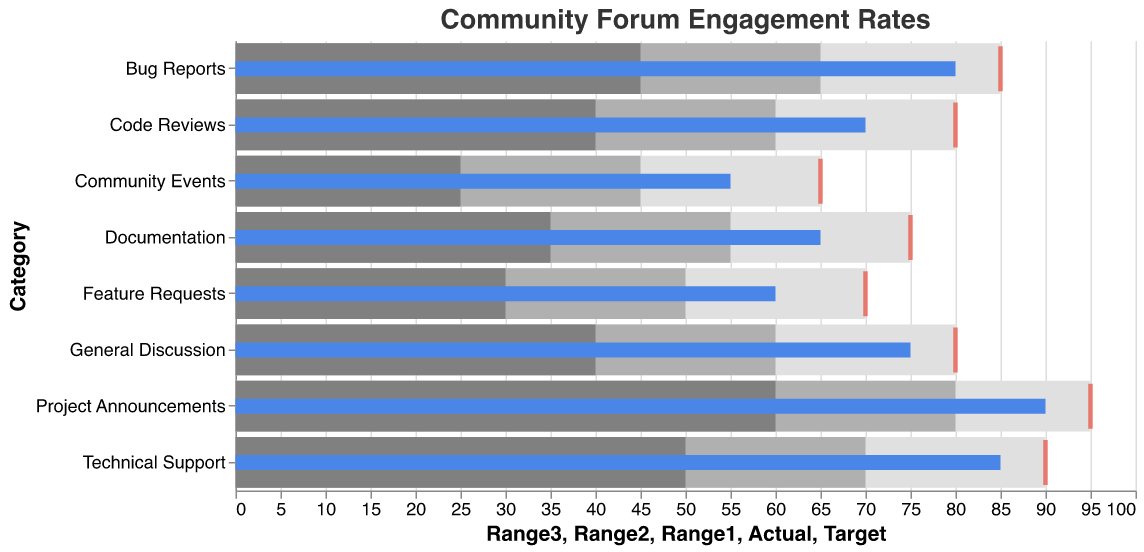What's the actual engagement rate for General Discussion? Look at the bar labeled "General Discussion." The actual engagement rate is indicated by the blue bar.
Answer: 75 How much higher is the Target rate than the Actual rate for Technical Support? Locate "Technical Support." The Actual rate is 85, and the Target rate is marked by a red tick at 90. Subtract Actual from Target (90 - 85).
Answer: 5 Which category has the highest engagement rate? Scan all categories for the highest blue bar. "Project Announcements" has the highest Actual rate.
Answer: Project Announcements Is the Actual rate for Bug Reports within the third range? For "Bug Reports," the third range ends at 85, and the Actual rate is 80. Since 80 is less than or equal to 85, it's within the range.
Answer: Yes What is the Target rate for Community Events? Find the red tick for "Community Events."
Answer: 65 Compare the Actual engagement rate of Documentation and Code Reviews. Which is higher? Look at the blue bars for both categories. "Code Reviews" has 70, and "Documentation" has 65.
Answer: Code Reviews Which two categories have Actual rates that exactly meet their third range limits? Identify categories where the blue bar is at the end of the dark gray area. "General Discussion" (80) and "Technical Support" (90).
Answer: General Discussion, Technical Support What is the average of the Actual rates for all categories? Sum Actual rates (75 + 85 + 60 + 80 + 90 + 65 + 70 + 55) and divide by the number of categories (8): (75+85+60+80+90+65+70+55)/8.
Answer: 72.5 Does any category's Actual rate surpass their Target rate? Compare Actual and Target rates for all categories. None of the blue bars are to the right of any red ticks.
Answer: No Which category has the smallest difference between Actual and Target rates? Calculate differences for each category and find the minimum: General Discussion (5), Technical Support (5), Feature Requests (10), Bug Reports (5), Project Announcements (5), Documentation (10), Code Reviews (10), Community Events (10). Smallest is 5 for "General Discussion," "Technical Support", "Bug Reports", and "Project Announcements."
Answer: General Discussion, Technical Support, Bug Reports, Project Announcements 